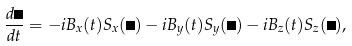<formula> <loc_0><loc_0><loc_500><loc_500>\frac { d \psi } { d t } = - i B _ { x } ( t ) S _ { x } ( \psi ) - i B _ { y } ( t ) S _ { y } ( \psi ) - i B _ { z } ( t ) S _ { z } ( \psi ) ,</formula> 